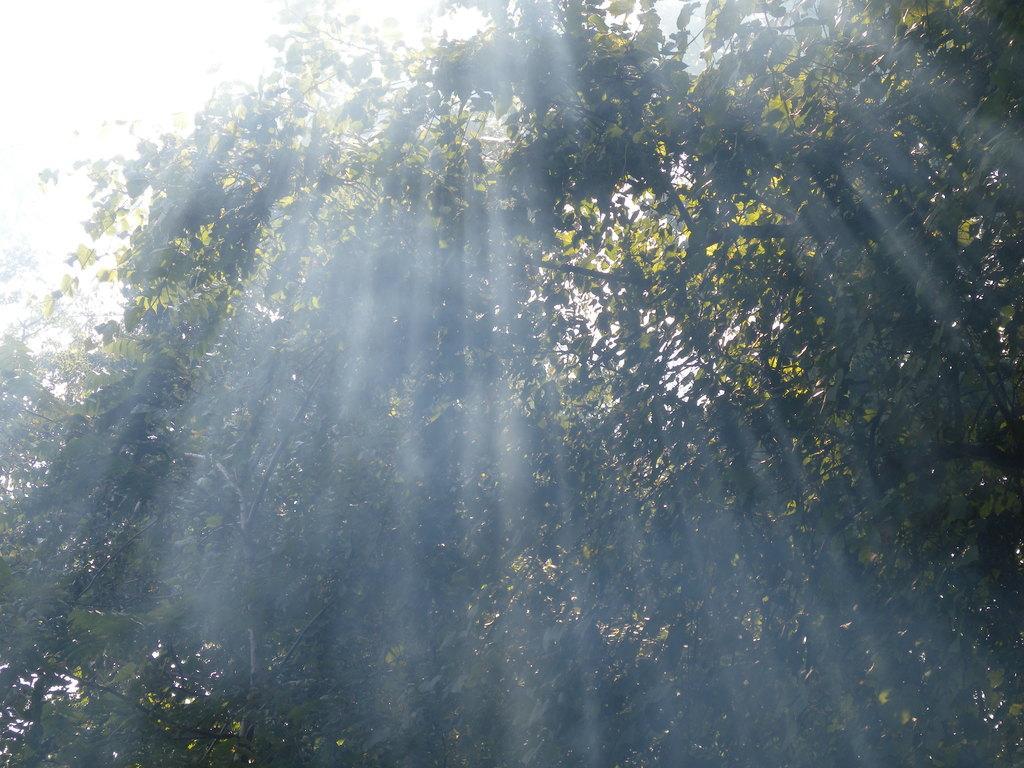In one or two sentences, can you explain what this image depicts? In this image I can see trees in green color. Background the sky is in white color. 